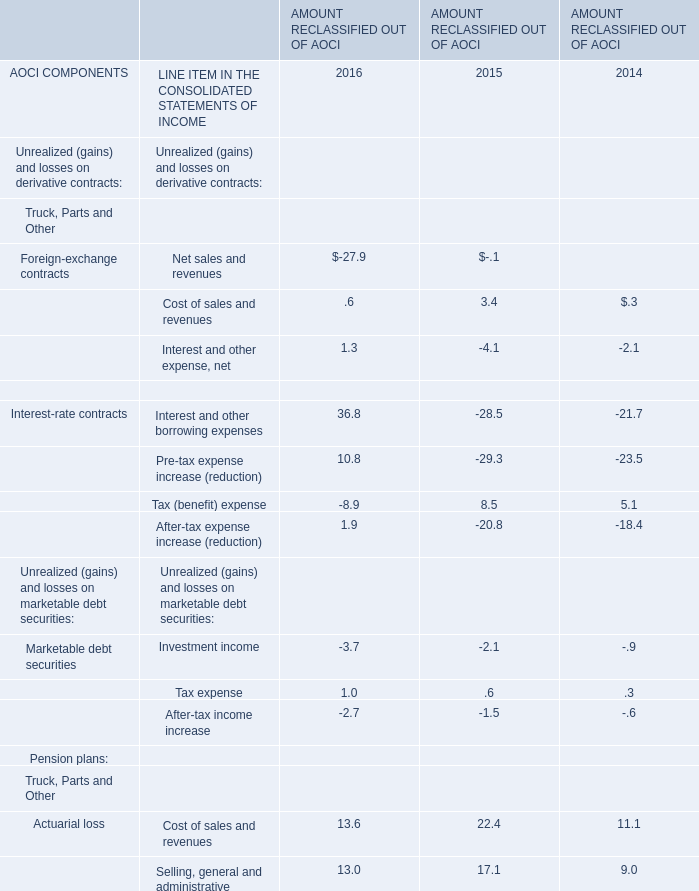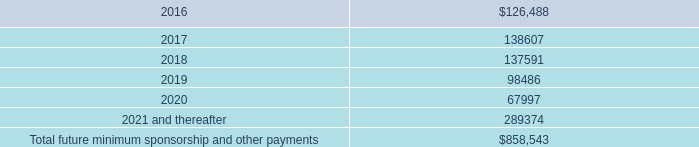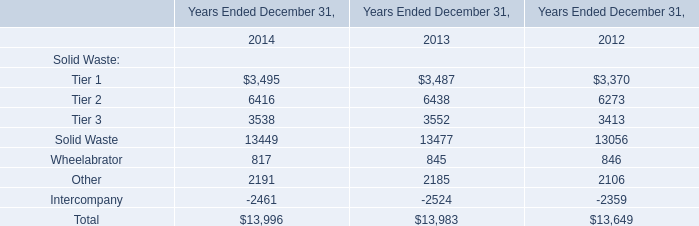In which year is Interest and other expense, net positive? 
Answer: 2016. 